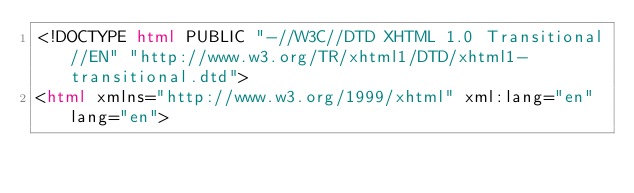Convert code to text. <code><loc_0><loc_0><loc_500><loc_500><_HTML_><!DOCTYPE html PUBLIC "-//W3C//DTD XHTML 1.0 Transitional//EN" "http://www.w3.org/TR/xhtml1/DTD/xhtml1-transitional.dtd">
<html xmlns="http://www.w3.org/1999/xhtml" xml:lang="en" lang="en"></code> 